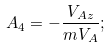<formula> <loc_0><loc_0><loc_500><loc_500>A _ { 4 } = - \frac { V _ { A z } } { m V _ { A } } ;</formula> 